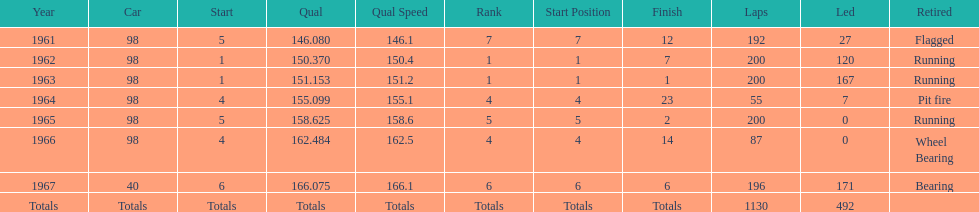What year(s) did parnelli finish at least 4th or better? 1963, 1965. 